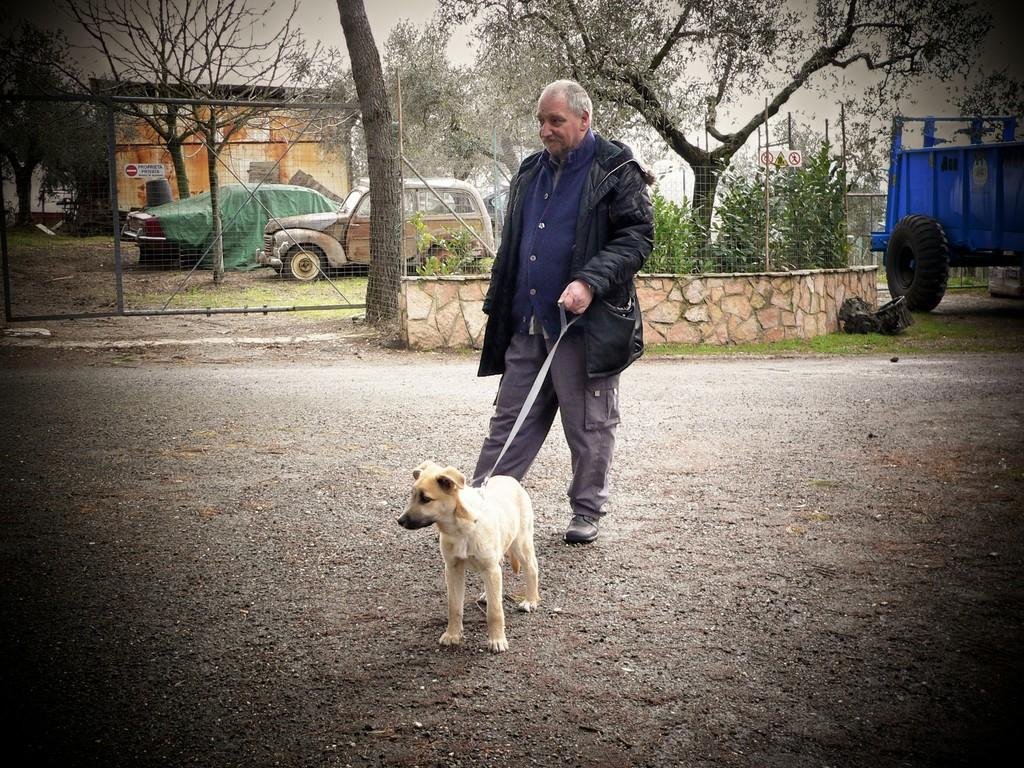Who is present in the image? There is a person in the image. What is the person holding? The person is holding a dog belt. What is attached to the dog belt? A dog is tied to the dog belt. What can be seen in the background of the image? There are trees, at least one building, plants, and vehicles in the background of the image. What type of brush is the person using to care for the church in the image? There is no church or brush present in the image. 